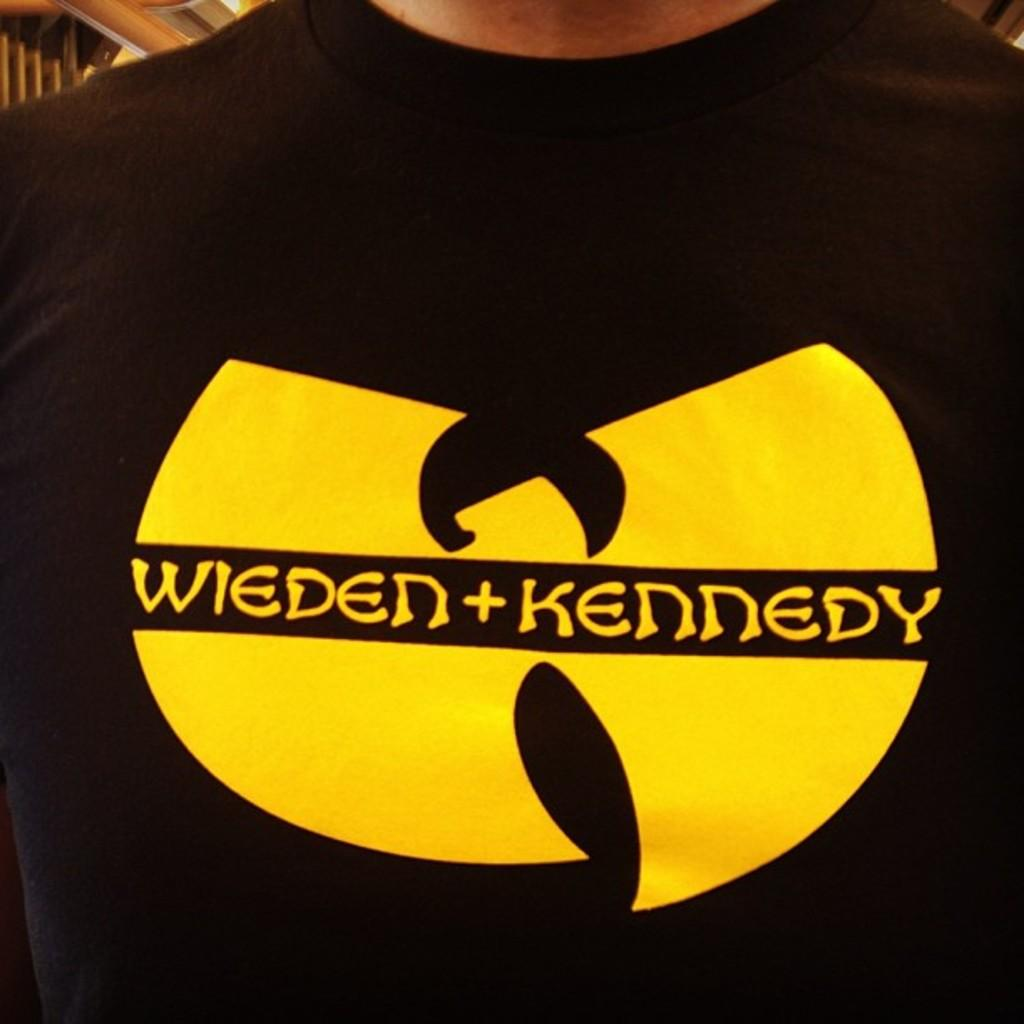What is the main subject of the image? There is a person standing in the image. What is the person wearing in the image? The person is wearing a black t-shirt. Is there any text or design on the t-shirt? Yes, there is something written on the t-shirt. How many pizzas are being delivered in the image? There are no pizzas or delivery mentioned in the image; it only features a person wearing a black t-shirt with something written on it. 